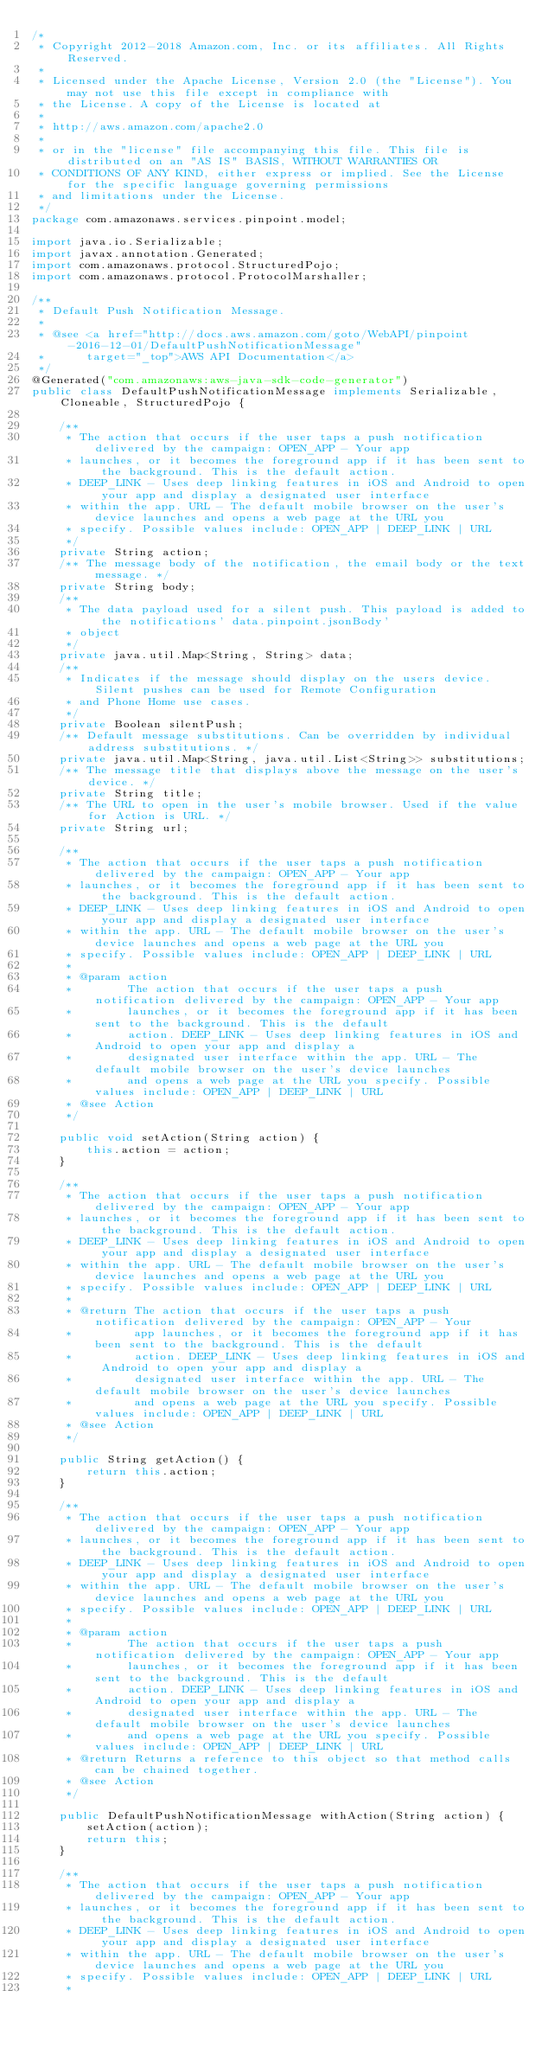<code> <loc_0><loc_0><loc_500><loc_500><_Java_>/*
 * Copyright 2012-2018 Amazon.com, Inc. or its affiliates. All Rights Reserved.
 * 
 * Licensed under the Apache License, Version 2.0 (the "License"). You may not use this file except in compliance with
 * the License. A copy of the License is located at
 * 
 * http://aws.amazon.com/apache2.0
 * 
 * or in the "license" file accompanying this file. This file is distributed on an "AS IS" BASIS, WITHOUT WARRANTIES OR
 * CONDITIONS OF ANY KIND, either express or implied. See the License for the specific language governing permissions
 * and limitations under the License.
 */
package com.amazonaws.services.pinpoint.model;

import java.io.Serializable;
import javax.annotation.Generated;
import com.amazonaws.protocol.StructuredPojo;
import com.amazonaws.protocol.ProtocolMarshaller;

/**
 * Default Push Notification Message.
 * 
 * @see <a href="http://docs.aws.amazon.com/goto/WebAPI/pinpoint-2016-12-01/DefaultPushNotificationMessage"
 *      target="_top">AWS API Documentation</a>
 */
@Generated("com.amazonaws:aws-java-sdk-code-generator")
public class DefaultPushNotificationMessage implements Serializable, Cloneable, StructuredPojo {

    /**
     * The action that occurs if the user taps a push notification delivered by the campaign: OPEN_APP - Your app
     * launches, or it becomes the foreground app if it has been sent to the background. This is the default action.
     * DEEP_LINK - Uses deep linking features in iOS and Android to open your app and display a designated user interface
     * within the app. URL - The default mobile browser on the user's device launches and opens a web page at the URL you
     * specify. Possible values include: OPEN_APP | DEEP_LINK | URL
     */
    private String action;
    /** The message body of the notification, the email body or the text message. */
    private String body;
    /**
     * The data payload used for a silent push. This payload is added to the notifications' data.pinpoint.jsonBody'
     * object
     */
    private java.util.Map<String, String> data;
    /**
     * Indicates if the message should display on the users device. Silent pushes can be used for Remote Configuration
     * and Phone Home use cases.
     */
    private Boolean silentPush;
    /** Default message substitutions. Can be overridden by individual address substitutions. */
    private java.util.Map<String, java.util.List<String>> substitutions;
    /** The message title that displays above the message on the user's device. */
    private String title;
    /** The URL to open in the user's mobile browser. Used if the value for Action is URL. */
    private String url;

    /**
     * The action that occurs if the user taps a push notification delivered by the campaign: OPEN_APP - Your app
     * launches, or it becomes the foreground app if it has been sent to the background. This is the default action.
     * DEEP_LINK - Uses deep linking features in iOS and Android to open your app and display a designated user interface
     * within the app. URL - The default mobile browser on the user's device launches and opens a web page at the URL you
     * specify. Possible values include: OPEN_APP | DEEP_LINK | URL
     * 
     * @param action
     *        The action that occurs if the user taps a push notification delivered by the campaign: OPEN_APP - Your app
     *        launches, or it becomes the foreground app if it has been sent to the background. This is the default
     *        action. DEEP_LINK - Uses deep linking features in iOS and Android to open your app and display a
     *        designated user interface within the app. URL - The default mobile browser on the user's device launches
     *        and opens a web page at the URL you specify. Possible values include: OPEN_APP | DEEP_LINK | URL
     * @see Action
     */

    public void setAction(String action) {
        this.action = action;
    }

    /**
     * The action that occurs if the user taps a push notification delivered by the campaign: OPEN_APP - Your app
     * launches, or it becomes the foreground app if it has been sent to the background. This is the default action.
     * DEEP_LINK - Uses deep linking features in iOS and Android to open your app and display a designated user interface
     * within the app. URL - The default mobile browser on the user's device launches and opens a web page at the URL you
     * specify. Possible values include: OPEN_APP | DEEP_LINK | URL
     * 
     * @return The action that occurs if the user taps a push notification delivered by the campaign: OPEN_APP - Your
     *         app launches, or it becomes the foreground app if it has been sent to the background. This is the default
     *         action. DEEP_LINK - Uses deep linking features in iOS and Android to open your app and display a
     *         designated user interface within the app. URL - The default mobile browser on the user's device launches
     *         and opens a web page at the URL you specify. Possible values include: OPEN_APP | DEEP_LINK | URL
     * @see Action
     */

    public String getAction() {
        return this.action;
    }

    /**
     * The action that occurs if the user taps a push notification delivered by the campaign: OPEN_APP - Your app
     * launches, or it becomes the foreground app if it has been sent to the background. This is the default action.
     * DEEP_LINK - Uses deep linking features in iOS and Android to open your app and display a designated user interface
     * within the app. URL - The default mobile browser on the user's device launches and opens a web page at the URL you
     * specify. Possible values include: OPEN_APP | DEEP_LINK | URL
     * 
     * @param action
     *        The action that occurs if the user taps a push notification delivered by the campaign: OPEN_APP - Your app
     *        launches, or it becomes the foreground app if it has been sent to the background. This is the default
     *        action. DEEP_LINK - Uses deep linking features in iOS and Android to open your app and display a
     *        designated user interface within the app. URL - The default mobile browser on the user's device launches
     *        and opens a web page at the URL you specify. Possible values include: OPEN_APP | DEEP_LINK | URL
     * @return Returns a reference to this object so that method calls can be chained together.
     * @see Action
     */

    public DefaultPushNotificationMessage withAction(String action) {
        setAction(action);
        return this;
    }

    /**
     * The action that occurs if the user taps a push notification delivered by the campaign: OPEN_APP - Your app
     * launches, or it becomes the foreground app if it has been sent to the background. This is the default action.
     * DEEP_LINK - Uses deep linking features in iOS and Android to open your app and display a designated user interface
     * within the app. URL - The default mobile browser on the user's device launches and opens a web page at the URL you
     * specify. Possible values include: OPEN_APP | DEEP_LINK | URL
     * </code> 